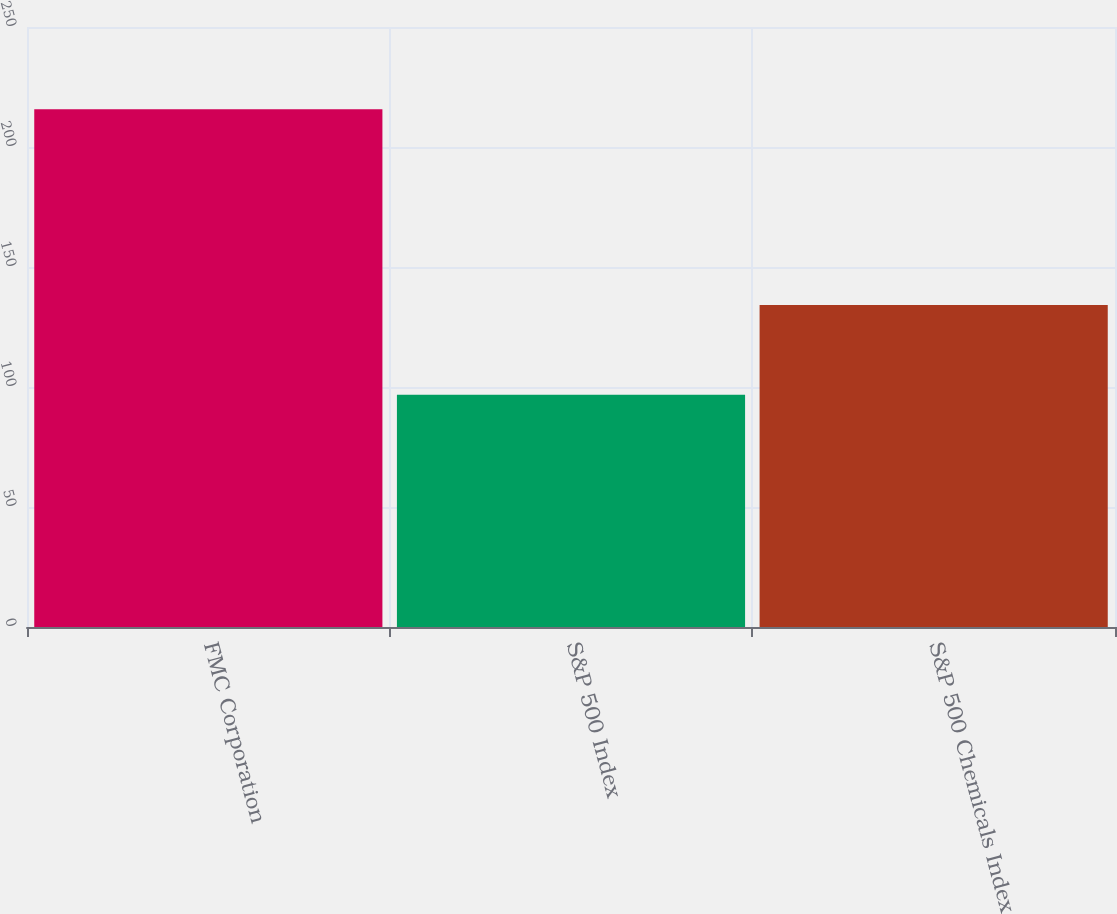<chart> <loc_0><loc_0><loc_500><loc_500><bar_chart><fcel>FMC Corporation<fcel>S&P 500 Index<fcel>S&P 500 Chemicals Index<nl><fcel>215.78<fcel>96.82<fcel>134.15<nl></chart> 